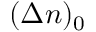<formula> <loc_0><loc_0><loc_500><loc_500>( \Delta { n } ) _ { 0 }</formula> 